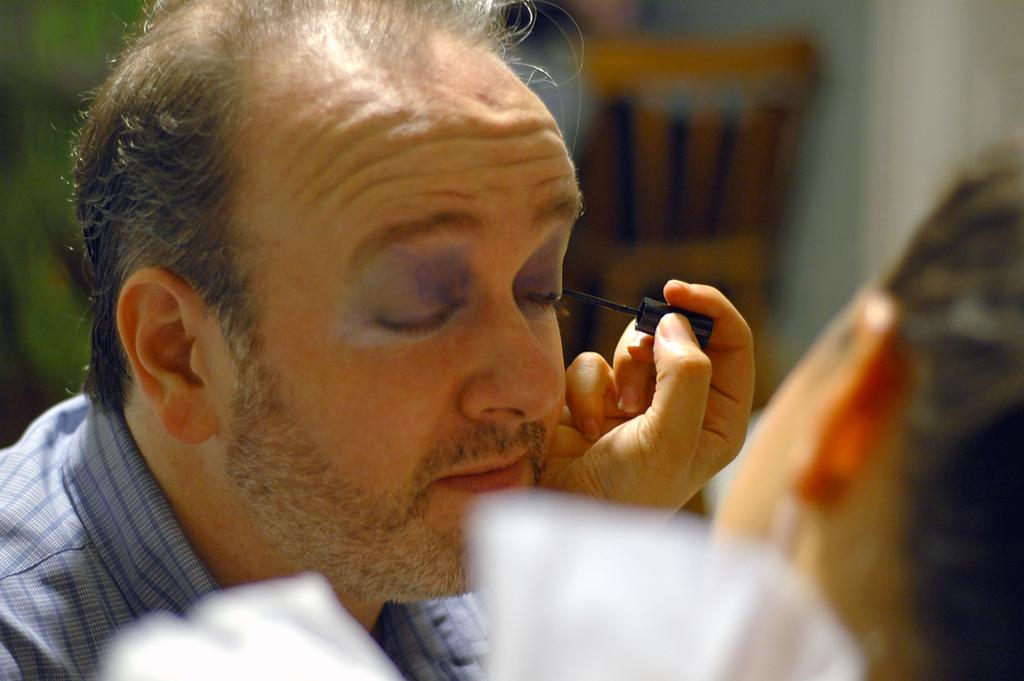How many people are present in the image? There are two people, a man and a woman, present in the image. What is the woman holding in the image? The woman is holding a liner. Can you describe the interaction between the man and the woman in the image? The provided facts do not give information about the interaction between the man and the woman. What route is the donkey taking in the image? There is no donkey present in the image, so it is not possible to determine the route it might be taking. 